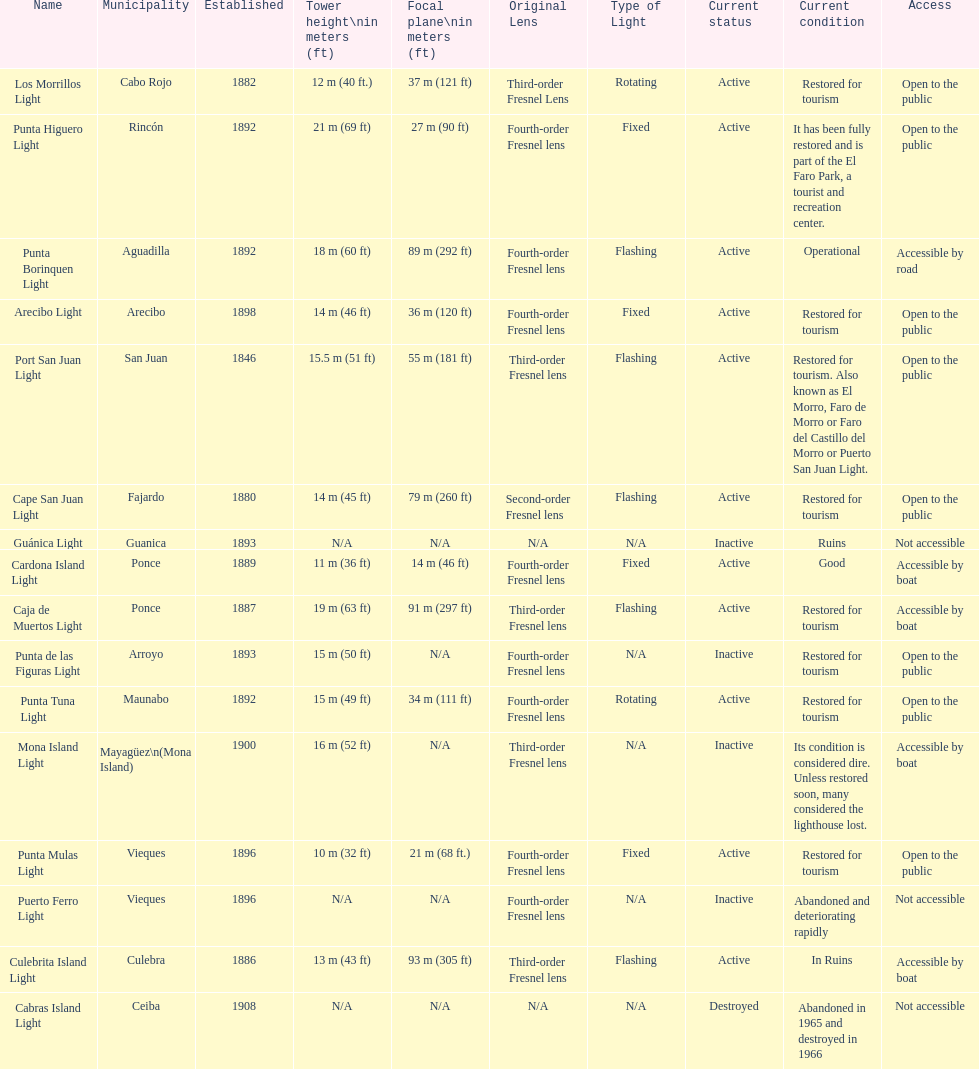Names of municipalities established before 1880 San Juan. 